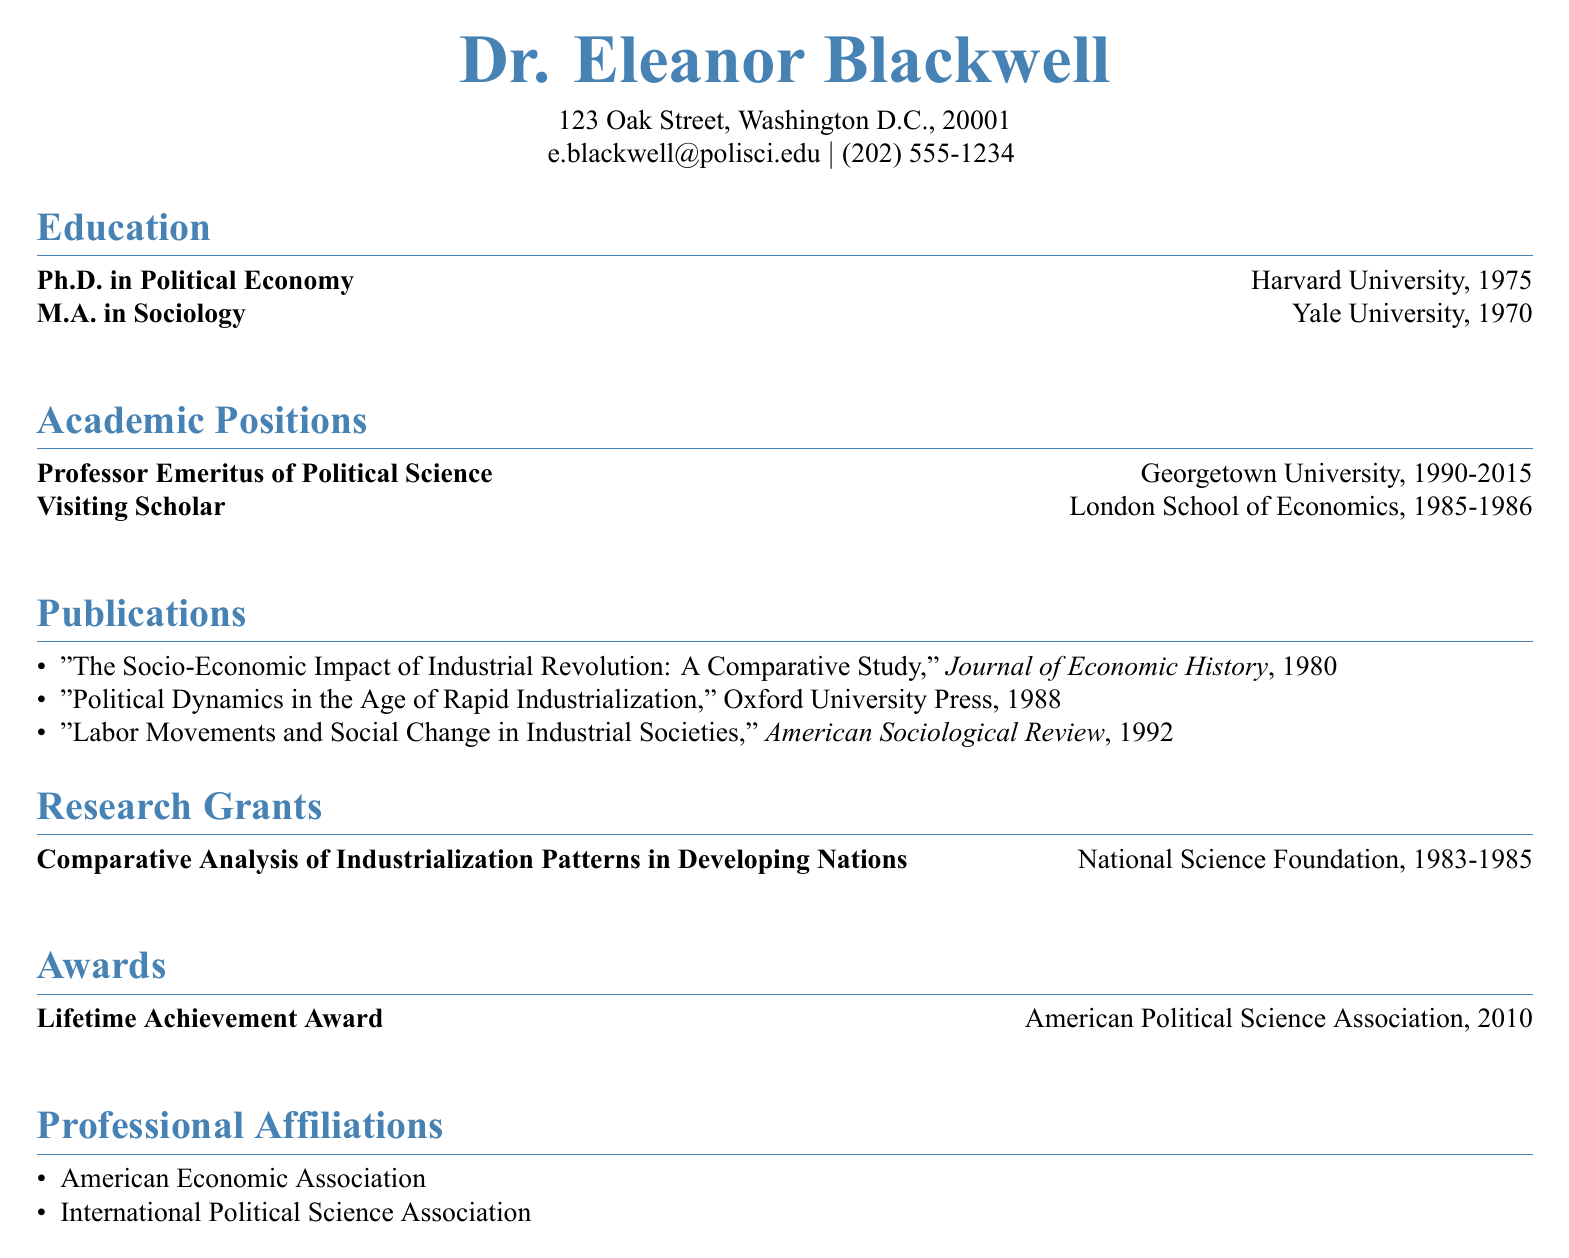What is Dr. Eleanor Blackwell's highest degree? The highest degree listed in the education section is the Ph.D. in Political Economy.
Answer: Ph.D. in Political Economy Which university awarded Dr. Blackwell her M.A.? The education section states that her M.A. was awarded by Yale University.
Answer: Yale University In which year did Dr. Blackwell receive her Ph.D.? The document specifies that she received her Ph.D. in 1975.
Answer: 1975 What is the title of Dr. Blackwell's publication in the American Sociological Review? The publication section lists "Labor Movements and Social Change in Industrial Societies" as her work in that journal.
Answer: Labor Movements and Social Change in Industrial Societies How many years did Dr. Blackwell serve at Georgetown University? The years of service indicated are from 1990 to 2015, totaling 25 years.
Answer: 25 years Which award did Dr. Blackwell receive in 2010? The awards section mentions the Lifetime Achievement Award from the American Political Science Association in 2010.
Answer: Lifetime Achievement Award What organization is Dr. Blackwell affiliated with? The professional affiliations list includes the American Economic Association and the International Political Science Association.
Answer: American Economic Association What was the focus of the research grant Dr. Blackwell received? The research grant titled "Comparative Analysis of Industrialization Patterns in Developing Nations" outlines its focus.
Answer: Comparative Analysis of Industrialization Patterns in Developing Nations 